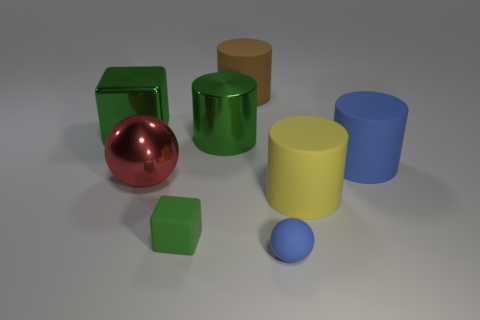What material is the large yellow object?
Give a very brief answer. Rubber. Do the large brown thing and the big blue object have the same shape?
Make the answer very short. Yes. Are there any other things that have the same shape as the large brown rubber thing?
Your response must be concise. Yes. There is a cube in front of the big blue matte object; is its color the same as the metal thing behind the big metal cylinder?
Provide a short and direct response. Yes. Is the number of big brown things on the left side of the big cube less than the number of metallic things that are to the left of the large red metal object?
Provide a short and direct response. Yes. There is a blue object right of the small blue rubber object; what shape is it?
Make the answer very short. Cylinder. There is a small block that is the same color as the large metal cylinder; what is its material?
Your answer should be compact. Rubber. How many other objects are there of the same material as the small green thing?
Provide a succinct answer. 4. There is a big brown rubber object; does it have the same shape as the blue rubber thing to the right of the yellow object?
Keep it short and to the point. Yes. What shape is the small green object that is made of the same material as the small blue sphere?
Your answer should be very brief. Cube. 